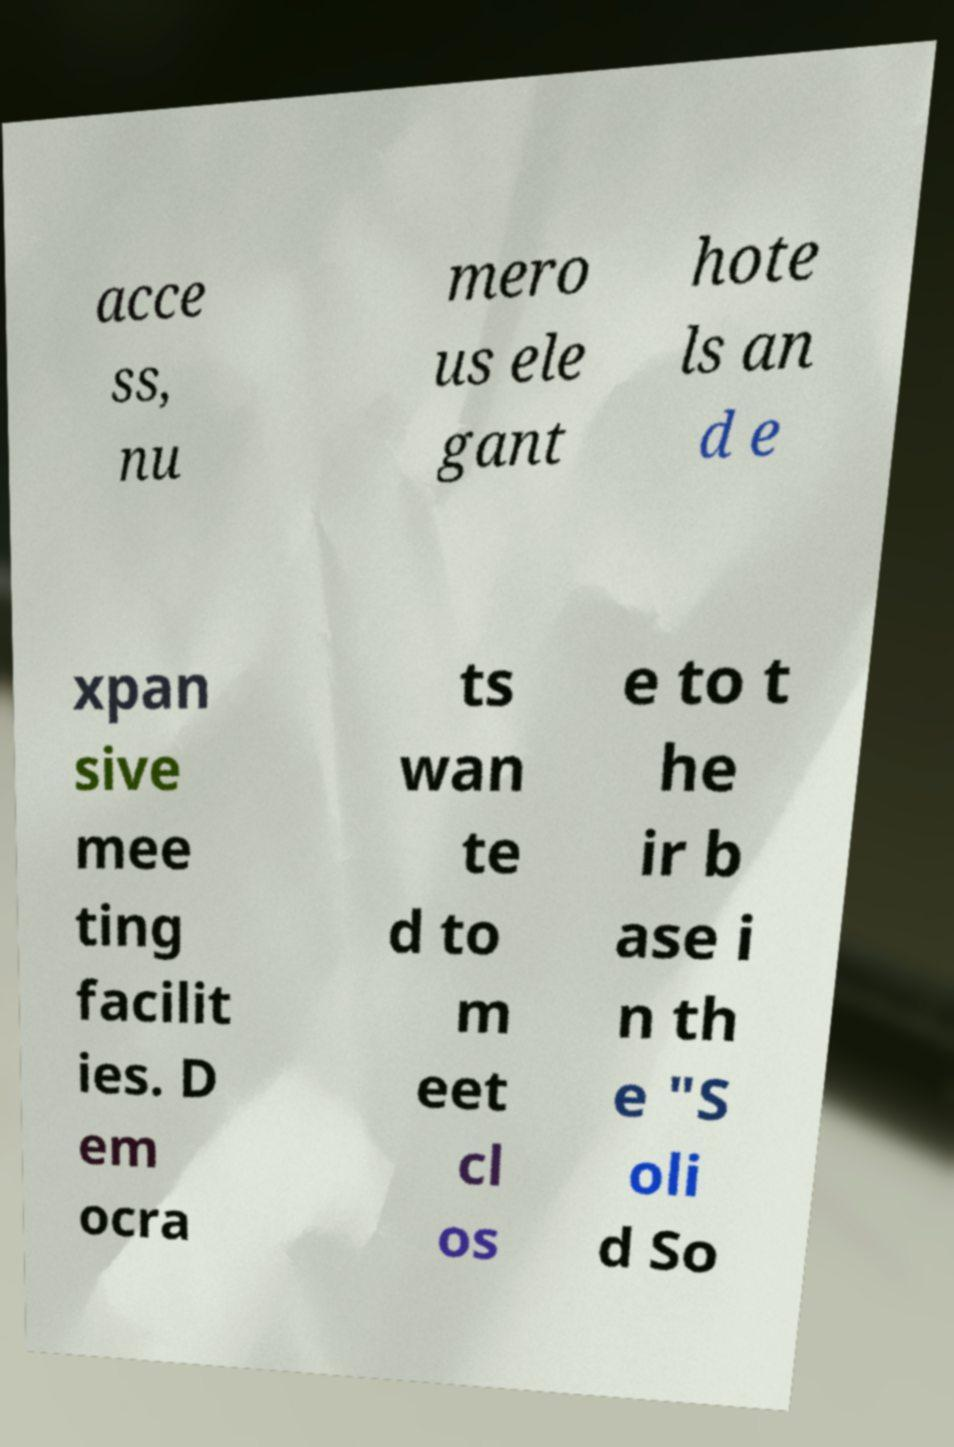Please identify and transcribe the text found in this image. acce ss, nu mero us ele gant hote ls an d e xpan sive mee ting facilit ies. D em ocra ts wan te d to m eet cl os e to t he ir b ase i n th e "S oli d So 